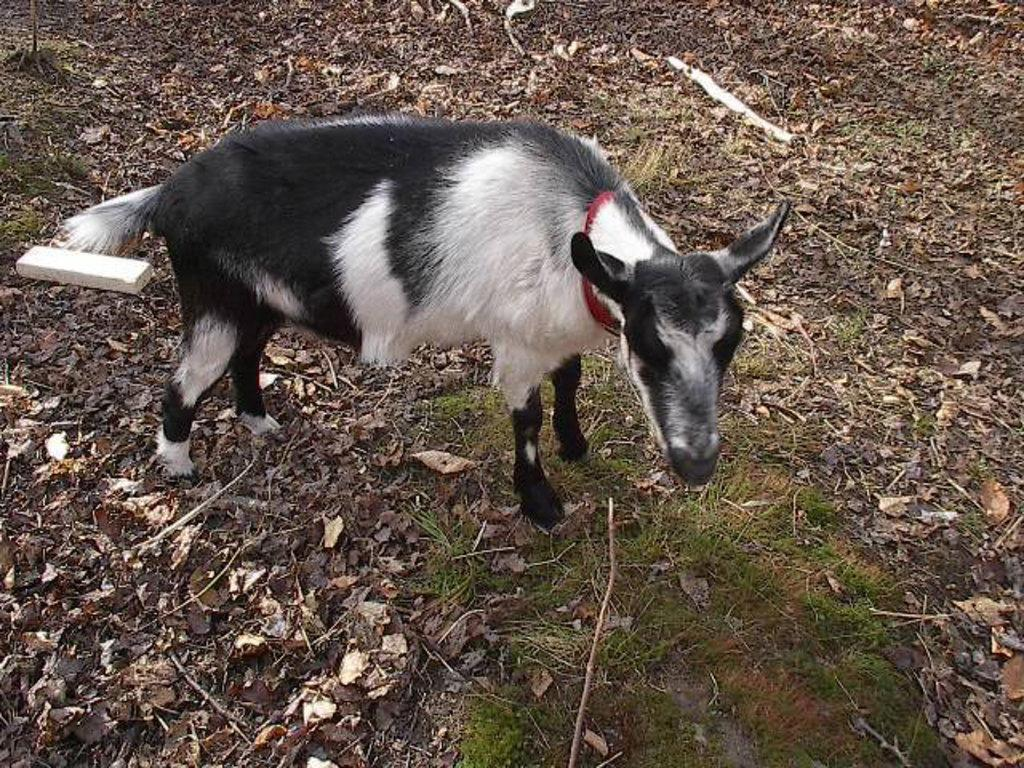What animal is present in the picture? There is a goat in the picture. What colors can be seen on the goat? The goat is black and white in color. What is the ground like in front of the goat? There is a green ground in front of the goat. What type of vegetation is present around the goat? There are dried leaves around the goat. What type of crayon is the goat holding in its mouth? There is no crayon present in the image, and the goat is not holding anything in its mouth. 